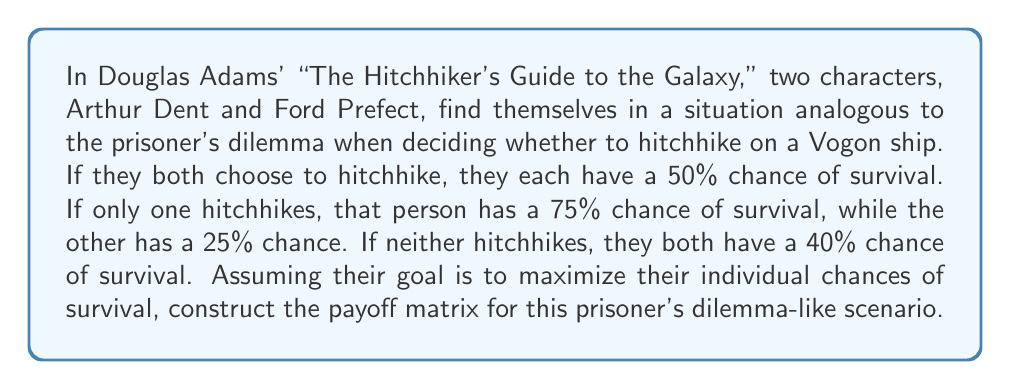Could you help me with this problem? To construct the payoff matrix for this prisoner's dilemma-like scenario, we need to follow these steps:

1. Identify the players: Arthur Dent and Ford Prefect

2. Identify the strategies: Hitchhike or Don't Hitchhike

3. Calculate the payoffs for each combination of strategies:

   a) Both Hitchhike: 50% survival chance for each
   b) One Hitchhikes, One Doesn't: 75% for the hitchhiker, 25% for the non-hitchhiker
   c) Neither Hitchhikes: 40% survival chance for each

4. Construct the matrix:

Let's use the convention that the first number in each cell represents Arthur's payoff, and the second number represents Ford's payoff.

$$
\begin{array}{c|c|c}
\text{Arthur } \backslash \text{ Ford} & \text{Hitchhike} & \text{Don't Hitchhike} \\
\hline
\text{Hitchhike} & (50, 50) & (75, 25) \\
\hline
\text{Don't Hitchhike} & (25, 75) & (40, 40)
\end{array}
$$

This matrix represents a prisoner's dilemma because:

1. Each player has a dominant strategy (Hitchhike), as it always yields a higher payoff regardless of the other player's choice.
2. The Nash equilibrium (Hitchhike, Hitchhike) is Pareto inefficient, as (Don't Hitchhike, Don't Hitchhike) would yield a better outcome for both players.
Answer: The payoff matrix for the prisoner's dilemma-like scenario in "The Hitchhiker's Guide to the Galaxy" is:

$$
\begin{array}{c|c|c}
\text{Arthur } \backslash \text{ Ford} & \text{Hitchhike} & \text{Don't Hitchhike} \\
\hline
\text{Hitchhike} & (50, 50) & (75, 25) \\
\hline
\text{Don't Hitchhike} & (25, 75) & (40, 40)
\end{array}
$$ 